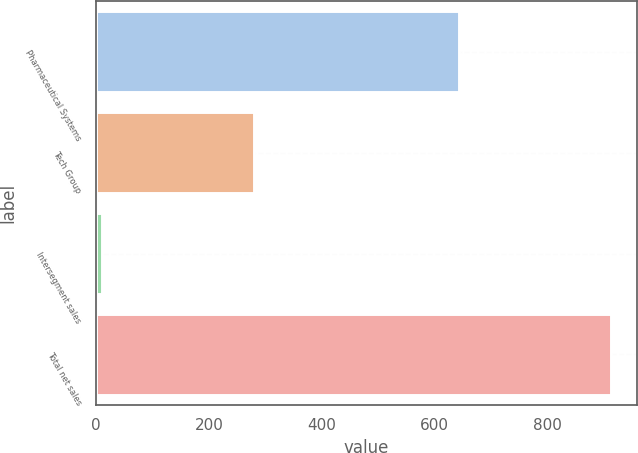<chart> <loc_0><loc_0><loc_500><loc_500><bar_chart><fcel>Pharmaceutical Systems<fcel>Tech Group<fcel>Intersegment sales<fcel>Total net sales<nl><fcel>644.1<fcel>279.2<fcel>10<fcel>913.3<nl></chart> 